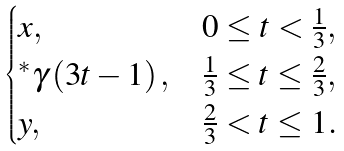<formula> <loc_0><loc_0><loc_500><loc_500>\begin{cases} x , & 0 \leq t < \frac { 1 } { 3 } , \\ ^ { \ast } \gamma \left ( 3 t - 1 \right ) , & \frac { 1 } { 3 } \leq t \leq \frac { 2 } { 3 } , \\ y , & \frac { 2 } { 3 } < t \leq 1 . \end{cases}</formula> 